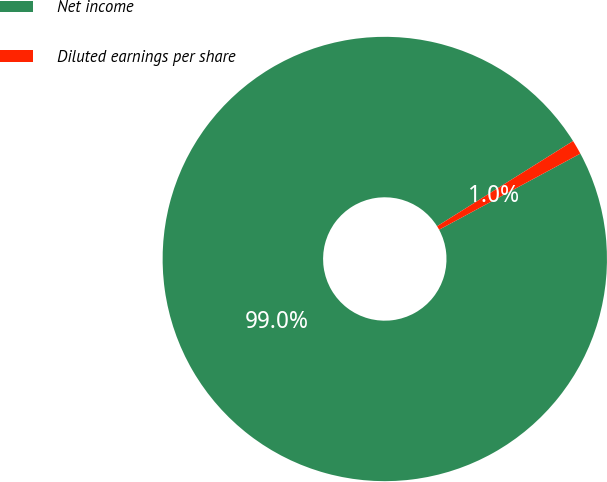Convert chart. <chart><loc_0><loc_0><loc_500><loc_500><pie_chart><fcel>Net income<fcel>Diluted earnings per share<nl><fcel>98.96%<fcel>1.04%<nl></chart> 